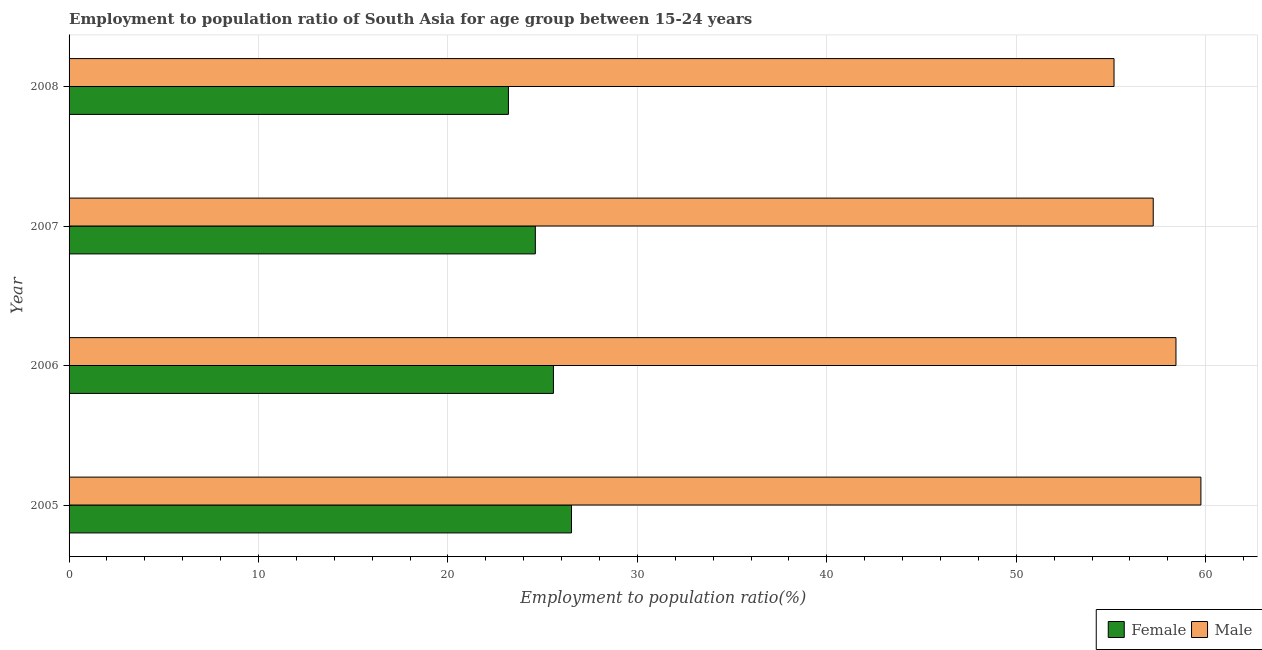How many bars are there on the 1st tick from the top?
Keep it short and to the point. 2. How many bars are there on the 4th tick from the bottom?
Keep it short and to the point. 2. What is the label of the 1st group of bars from the top?
Make the answer very short. 2008. In how many cases, is the number of bars for a given year not equal to the number of legend labels?
Make the answer very short. 0. What is the employment to population ratio(female) in 2006?
Your answer should be very brief. 25.57. Across all years, what is the maximum employment to population ratio(male)?
Offer a terse response. 59.74. Across all years, what is the minimum employment to population ratio(male)?
Your answer should be compact. 55.16. In which year was the employment to population ratio(male) minimum?
Your answer should be compact. 2008. What is the total employment to population ratio(male) in the graph?
Offer a very short reply. 230.56. What is the difference between the employment to population ratio(female) in 2006 and that in 2007?
Provide a succinct answer. 0.95. What is the difference between the employment to population ratio(female) in 2005 and the employment to population ratio(male) in 2007?
Provide a short and direct response. -30.71. What is the average employment to population ratio(male) per year?
Your response must be concise. 57.64. In the year 2005, what is the difference between the employment to population ratio(male) and employment to population ratio(female)?
Offer a terse response. 33.22. In how many years, is the employment to population ratio(male) greater than 60 %?
Your response must be concise. 0. What is the ratio of the employment to population ratio(female) in 2007 to that in 2008?
Keep it short and to the point. 1.06. Is the employment to population ratio(female) in 2007 less than that in 2008?
Make the answer very short. No. Is the difference between the employment to population ratio(male) in 2006 and 2007 greater than the difference between the employment to population ratio(female) in 2006 and 2007?
Give a very brief answer. Yes. What is the difference between the highest and the second highest employment to population ratio(female)?
Offer a very short reply. 0.95. What is the difference between the highest and the lowest employment to population ratio(female)?
Give a very brief answer. 3.33. In how many years, is the employment to population ratio(female) greater than the average employment to population ratio(female) taken over all years?
Your response must be concise. 2. Is the sum of the employment to population ratio(male) in 2005 and 2008 greater than the maximum employment to population ratio(female) across all years?
Offer a very short reply. Yes. What does the 1st bar from the bottom in 2008 represents?
Offer a very short reply. Female. Are all the bars in the graph horizontal?
Your answer should be very brief. Yes. What is the difference between two consecutive major ticks on the X-axis?
Offer a terse response. 10. Are the values on the major ticks of X-axis written in scientific E-notation?
Your answer should be compact. No. Does the graph contain grids?
Give a very brief answer. Yes. Where does the legend appear in the graph?
Keep it short and to the point. Bottom right. How many legend labels are there?
Your answer should be compact. 2. How are the legend labels stacked?
Offer a very short reply. Horizontal. What is the title of the graph?
Make the answer very short. Employment to population ratio of South Asia for age group between 15-24 years. What is the label or title of the X-axis?
Keep it short and to the point. Employment to population ratio(%). What is the Employment to population ratio(%) in Female in 2005?
Your answer should be very brief. 26.52. What is the Employment to population ratio(%) of Male in 2005?
Provide a succinct answer. 59.74. What is the Employment to population ratio(%) in Female in 2006?
Ensure brevity in your answer.  25.57. What is the Employment to population ratio(%) of Male in 2006?
Give a very brief answer. 58.43. What is the Employment to population ratio(%) of Female in 2007?
Make the answer very short. 24.61. What is the Employment to population ratio(%) in Male in 2007?
Offer a very short reply. 57.23. What is the Employment to population ratio(%) of Female in 2008?
Offer a terse response. 23.19. What is the Employment to population ratio(%) in Male in 2008?
Your answer should be compact. 55.16. Across all years, what is the maximum Employment to population ratio(%) of Female?
Your answer should be very brief. 26.52. Across all years, what is the maximum Employment to population ratio(%) of Male?
Make the answer very short. 59.74. Across all years, what is the minimum Employment to population ratio(%) in Female?
Give a very brief answer. 23.19. Across all years, what is the minimum Employment to population ratio(%) in Male?
Offer a terse response. 55.16. What is the total Employment to population ratio(%) in Female in the graph?
Your response must be concise. 99.89. What is the total Employment to population ratio(%) of Male in the graph?
Offer a terse response. 230.56. What is the difference between the Employment to population ratio(%) of Female in 2005 and that in 2006?
Offer a terse response. 0.95. What is the difference between the Employment to population ratio(%) in Male in 2005 and that in 2006?
Ensure brevity in your answer.  1.32. What is the difference between the Employment to population ratio(%) of Female in 2005 and that in 2007?
Your answer should be very brief. 1.91. What is the difference between the Employment to population ratio(%) of Male in 2005 and that in 2007?
Your answer should be very brief. 2.52. What is the difference between the Employment to population ratio(%) of Female in 2005 and that in 2008?
Keep it short and to the point. 3.33. What is the difference between the Employment to population ratio(%) in Male in 2005 and that in 2008?
Offer a very short reply. 4.59. What is the difference between the Employment to population ratio(%) in Female in 2006 and that in 2007?
Ensure brevity in your answer.  0.95. What is the difference between the Employment to population ratio(%) in Male in 2006 and that in 2007?
Provide a succinct answer. 1.2. What is the difference between the Employment to population ratio(%) in Female in 2006 and that in 2008?
Offer a terse response. 2.38. What is the difference between the Employment to population ratio(%) of Male in 2006 and that in 2008?
Give a very brief answer. 3.27. What is the difference between the Employment to population ratio(%) in Female in 2007 and that in 2008?
Offer a very short reply. 1.42. What is the difference between the Employment to population ratio(%) in Male in 2007 and that in 2008?
Your answer should be compact. 2.07. What is the difference between the Employment to population ratio(%) of Female in 2005 and the Employment to population ratio(%) of Male in 2006?
Provide a short and direct response. -31.91. What is the difference between the Employment to population ratio(%) in Female in 2005 and the Employment to population ratio(%) in Male in 2007?
Offer a very short reply. -30.71. What is the difference between the Employment to population ratio(%) of Female in 2005 and the Employment to population ratio(%) of Male in 2008?
Your response must be concise. -28.64. What is the difference between the Employment to population ratio(%) in Female in 2006 and the Employment to population ratio(%) in Male in 2007?
Your answer should be very brief. -31.66. What is the difference between the Employment to population ratio(%) in Female in 2006 and the Employment to population ratio(%) in Male in 2008?
Provide a short and direct response. -29.59. What is the difference between the Employment to population ratio(%) in Female in 2007 and the Employment to population ratio(%) in Male in 2008?
Offer a very short reply. -30.55. What is the average Employment to population ratio(%) in Female per year?
Offer a terse response. 24.97. What is the average Employment to population ratio(%) of Male per year?
Provide a short and direct response. 57.64. In the year 2005, what is the difference between the Employment to population ratio(%) of Female and Employment to population ratio(%) of Male?
Keep it short and to the point. -33.22. In the year 2006, what is the difference between the Employment to population ratio(%) of Female and Employment to population ratio(%) of Male?
Offer a terse response. -32.86. In the year 2007, what is the difference between the Employment to population ratio(%) of Female and Employment to population ratio(%) of Male?
Provide a short and direct response. -32.62. In the year 2008, what is the difference between the Employment to population ratio(%) of Female and Employment to population ratio(%) of Male?
Give a very brief answer. -31.97. What is the ratio of the Employment to population ratio(%) in Female in 2005 to that in 2006?
Provide a short and direct response. 1.04. What is the ratio of the Employment to population ratio(%) of Male in 2005 to that in 2006?
Provide a short and direct response. 1.02. What is the ratio of the Employment to population ratio(%) in Female in 2005 to that in 2007?
Give a very brief answer. 1.08. What is the ratio of the Employment to population ratio(%) in Male in 2005 to that in 2007?
Offer a very short reply. 1.04. What is the ratio of the Employment to population ratio(%) of Female in 2005 to that in 2008?
Offer a terse response. 1.14. What is the ratio of the Employment to population ratio(%) of Male in 2005 to that in 2008?
Your answer should be compact. 1.08. What is the ratio of the Employment to population ratio(%) in Female in 2006 to that in 2007?
Your answer should be very brief. 1.04. What is the ratio of the Employment to population ratio(%) of Male in 2006 to that in 2007?
Provide a succinct answer. 1.02. What is the ratio of the Employment to population ratio(%) in Female in 2006 to that in 2008?
Keep it short and to the point. 1.1. What is the ratio of the Employment to population ratio(%) of Male in 2006 to that in 2008?
Keep it short and to the point. 1.06. What is the ratio of the Employment to population ratio(%) of Female in 2007 to that in 2008?
Keep it short and to the point. 1.06. What is the ratio of the Employment to population ratio(%) in Male in 2007 to that in 2008?
Provide a succinct answer. 1.04. What is the difference between the highest and the second highest Employment to population ratio(%) in Female?
Provide a short and direct response. 0.95. What is the difference between the highest and the second highest Employment to population ratio(%) of Male?
Your answer should be compact. 1.32. What is the difference between the highest and the lowest Employment to population ratio(%) in Female?
Ensure brevity in your answer.  3.33. What is the difference between the highest and the lowest Employment to population ratio(%) of Male?
Offer a very short reply. 4.59. 